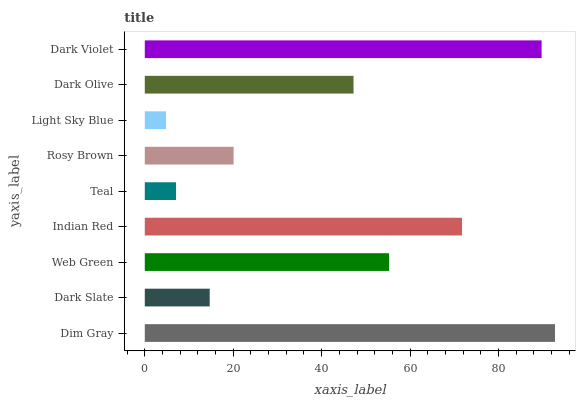Is Light Sky Blue the minimum?
Answer yes or no. Yes. Is Dim Gray the maximum?
Answer yes or no. Yes. Is Dark Slate the minimum?
Answer yes or no. No. Is Dark Slate the maximum?
Answer yes or no. No. Is Dim Gray greater than Dark Slate?
Answer yes or no. Yes. Is Dark Slate less than Dim Gray?
Answer yes or no. Yes. Is Dark Slate greater than Dim Gray?
Answer yes or no. No. Is Dim Gray less than Dark Slate?
Answer yes or no. No. Is Dark Olive the high median?
Answer yes or no. Yes. Is Dark Olive the low median?
Answer yes or no. Yes. Is Dark Slate the high median?
Answer yes or no. No. Is Web Green the low median?
Answer yes or no. No. 